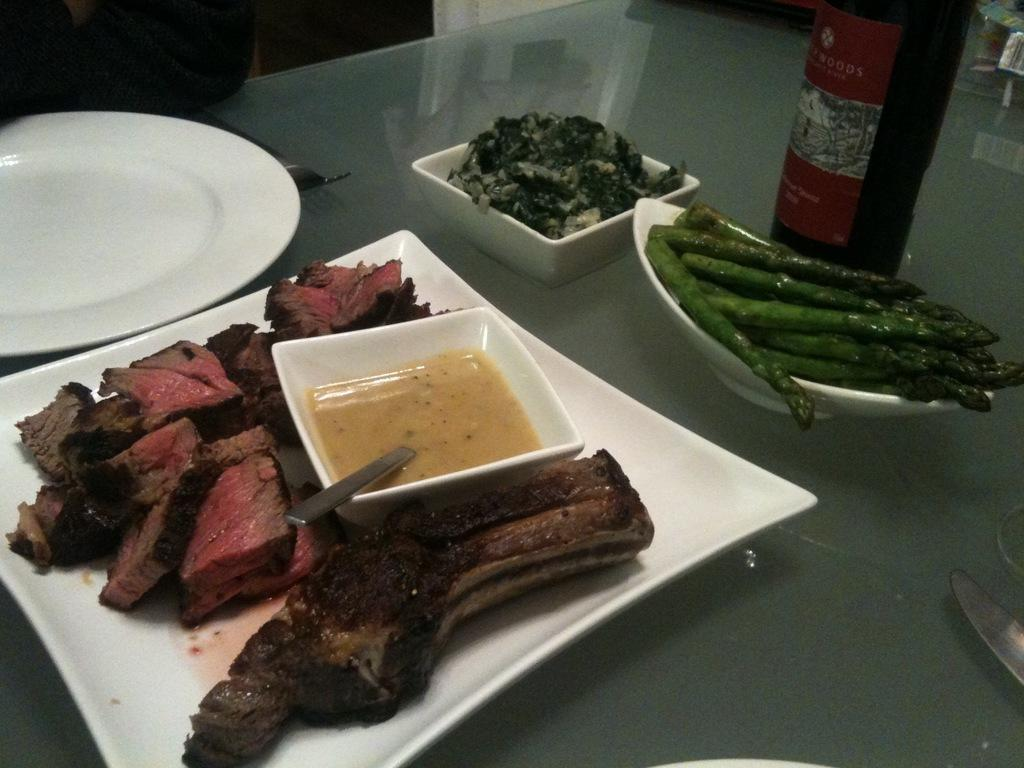What type of food items can be seen in the image? There are food items in bowls and on a plate in the image. How many plates are visible in the image? There are two plates visible in the image, one with food items and one empty. What utensils are present in the image? There is a fork and a knife in the image. What type of beverage container is on the table in the image? There is a wine bottle on the table in the image. What type of parcel is being delivered in the image? There is no parcel present in the image; it features food items in bowls, on a plate, and utensils. Is there any smoke visible in the image? No, there is no smoke visible in the image. 